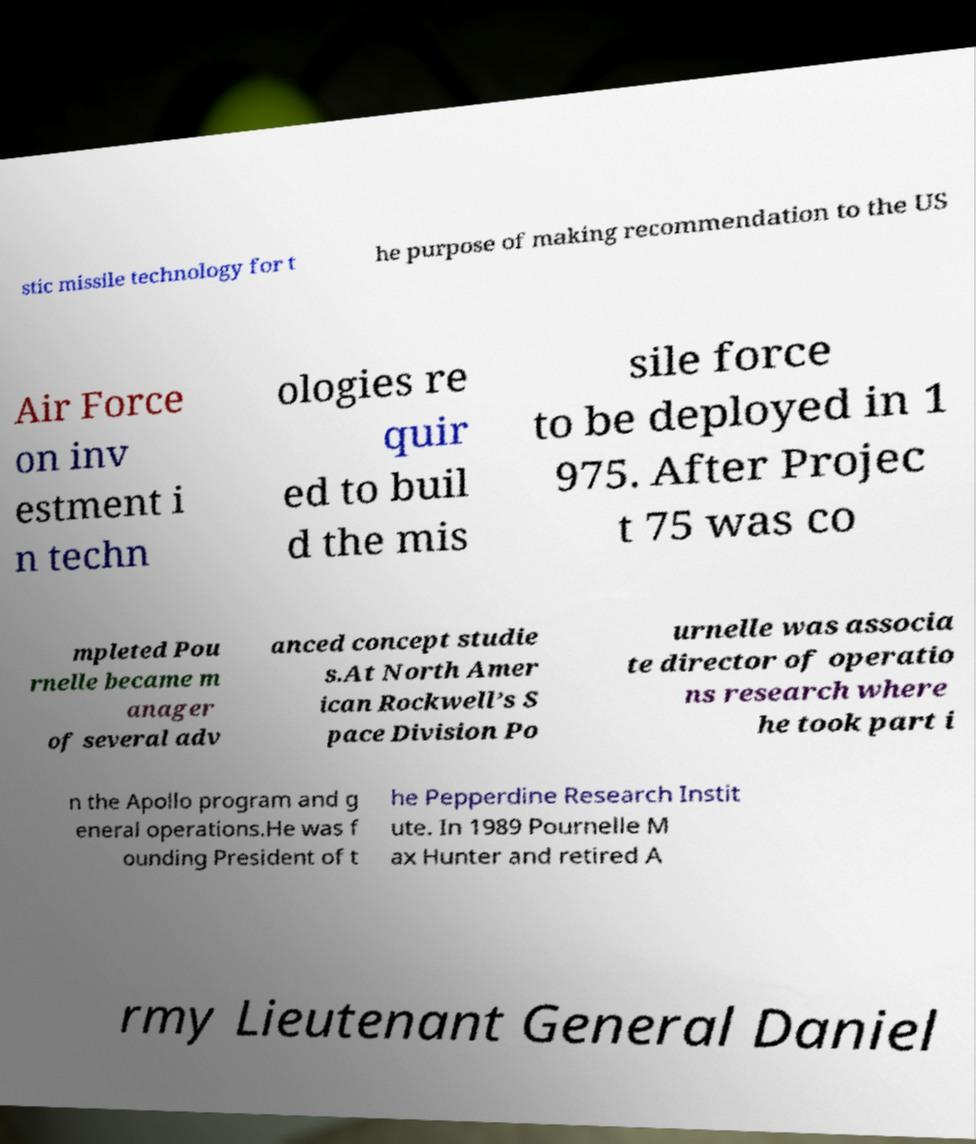Could you assist in decoding the text presented in this image and type it out clearly? stic missile technology for t he purpose of making recommendation to the US Air Force on inv estment i n techn ologies re quir ed to buil d the mis sile force to be deployed in 1 975. After Projec t 75 was co mpleted Pou rnelle became m anager of several adv anced concept studie s.At North Amer ican Rockwell’s S pace Division Po urnelle was associa te director of operatio ns research where he took part i n the Apollo program and g eneral operations.He was f ounding President of t he Pepperdine Research Instit ute. In 1989 Pournelle M ax Hunter and retired A rmy Lieutenant General Daniel 